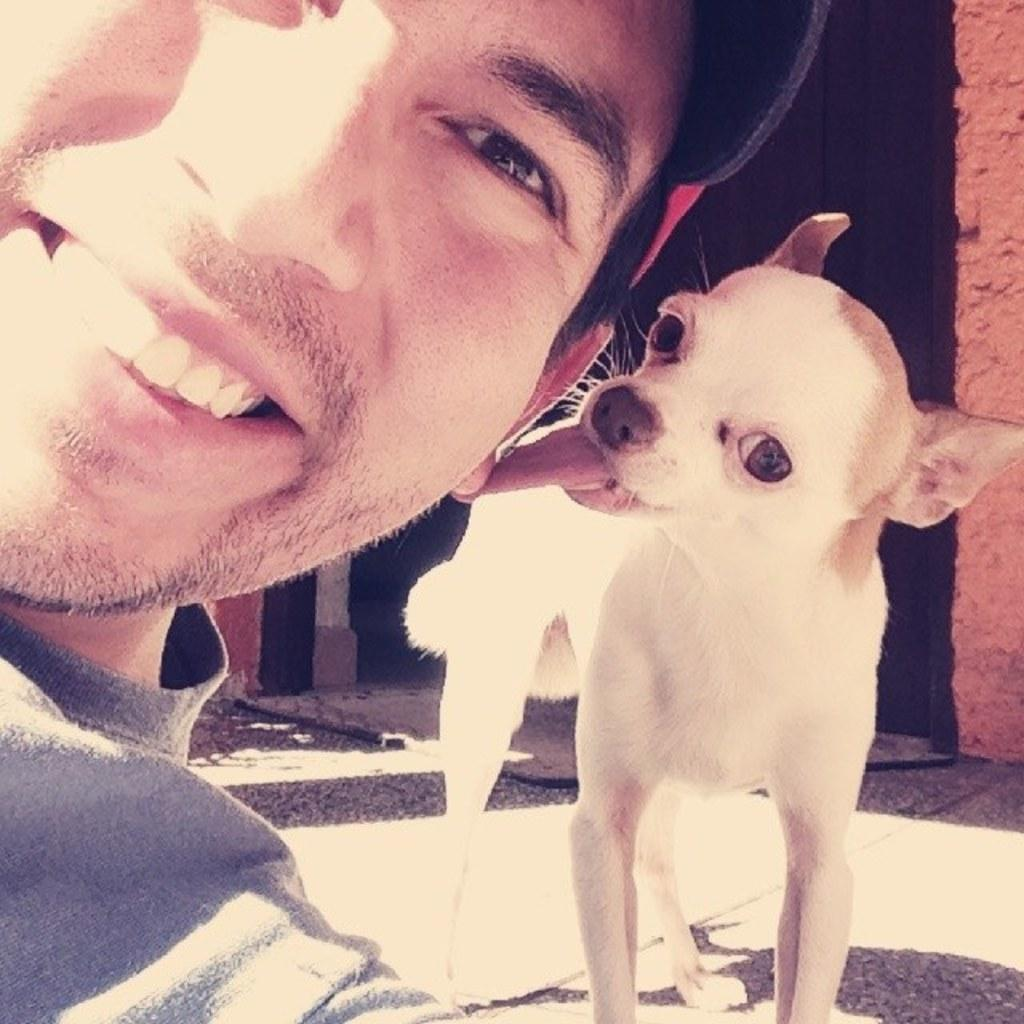Who is present in the image? There is a man in the image. What is the man doing in the image? The man is smiling in the image. Is there anyone else with the man in the image? Yes, there is another man beside the first man in the image. What can be seen in the background of the image? There is a dog in the background of the image. What is visible in the image that might indicate a boundary or barrier? There is a wall visible in the image. What is the father of the dog pointing at in the image? There is no dog in the image that is being pointed at by a father, as the facts provided do not mention a dog being pointed at or a father being present. 